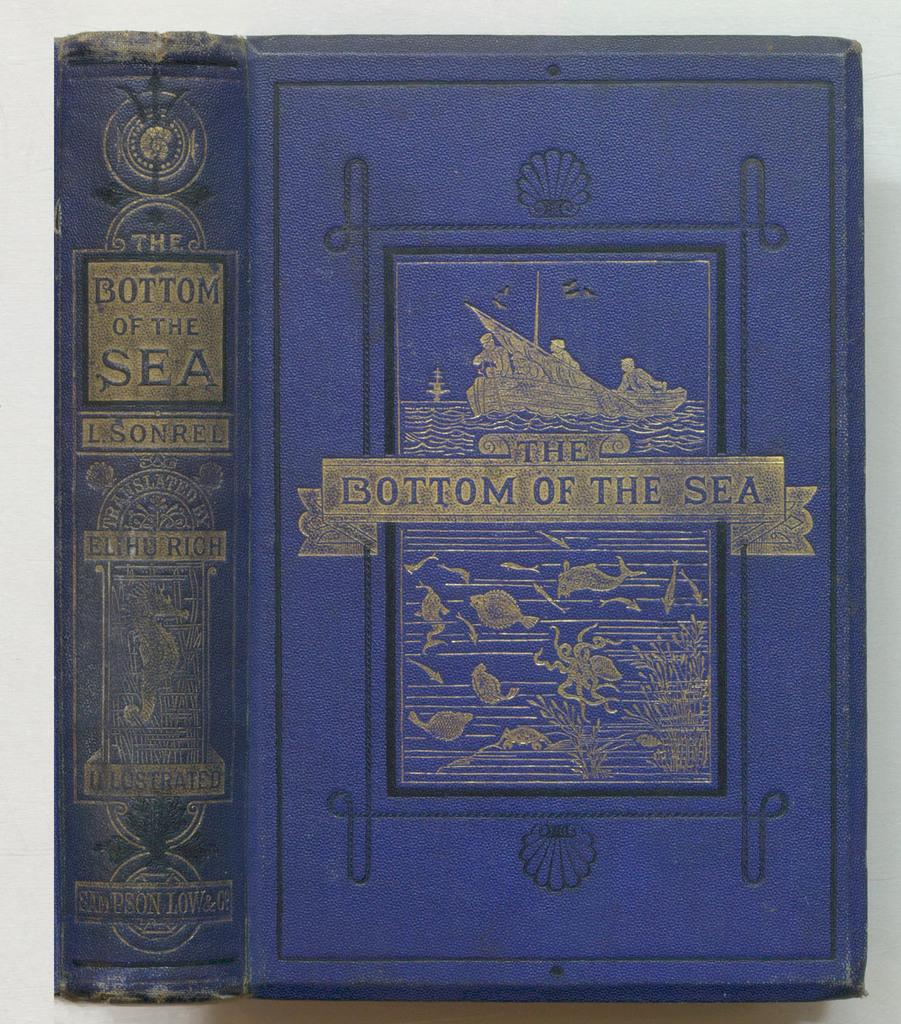<image>
Render a clear and concise summary of the photo. A copy of The Bottom of the Sea by L. Sonrel. 